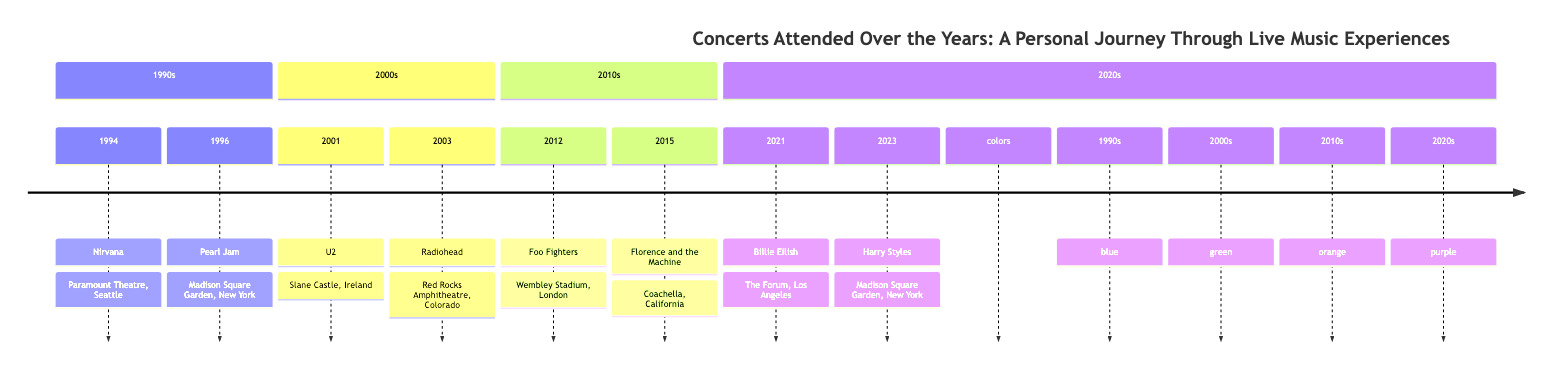What was the headliner for the concert in 1994? The diagram shows that the concert headliner in 1994 was Nirvana.
Answer: Nirvana How many concerts were attended in the 2000s? By looking at the 2000s section of the diagram, there are two concerts listed: U2 in 2001 and Radiohead in 2003.
Answer: 2 Which concert had the venue Madison Square Garden? The diagram indicates that both Pearl Jam in 1996 and Harry Styles in 2023 performed at Madison Square Garden.
Answer: Pearl Jam and Harry Styles What year did the concert by Florence and the Machine occur? From the timeline, it can be observed that Florence and the Machine performed in 2015.
Answer: 2015 What color represents the 2010s section of the timeline? The diagram specifies that the 2010s section is represented in orange color.
Answer: orange Which artist performed at Slane Castle in 2001? According to the information in the diagram, the headliner for the concert at Slane Castle in 2001 was U2.
Answer: U2 What was the last concert attended according to the diagram? The last entry on the timeline shows that Harry Styles performed in 2023, indicating it was the most recent concert attended.
Answer: Harry Styles How many concerts featured in the 1990s included headliners that are also in the 2000s? The diagram lists Nirvana and Pearl Jam in the 1990s, while U2 and Radiohead are in the 2000s. Comparing the headliners, there are no repeats.
Answer: 0 What was unique about the concert by Billie Eilish in 2021? The diagram mentions that Billie Eilish’s performance had a different vibe, marking it distinct from earlier concerts, indicating a different style.
Answer: Different vibe 